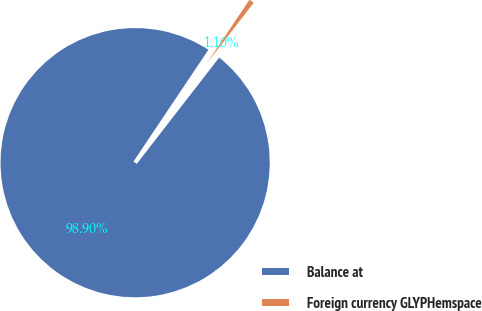<chart> <loc_0><loc_0><loc_500><loc_500><pie_chart><fcel>Balance at<fcel>Foreign currency GLYPHemspace<nl><fcel>98.9%<fcel>1.1%<nl></chart> 